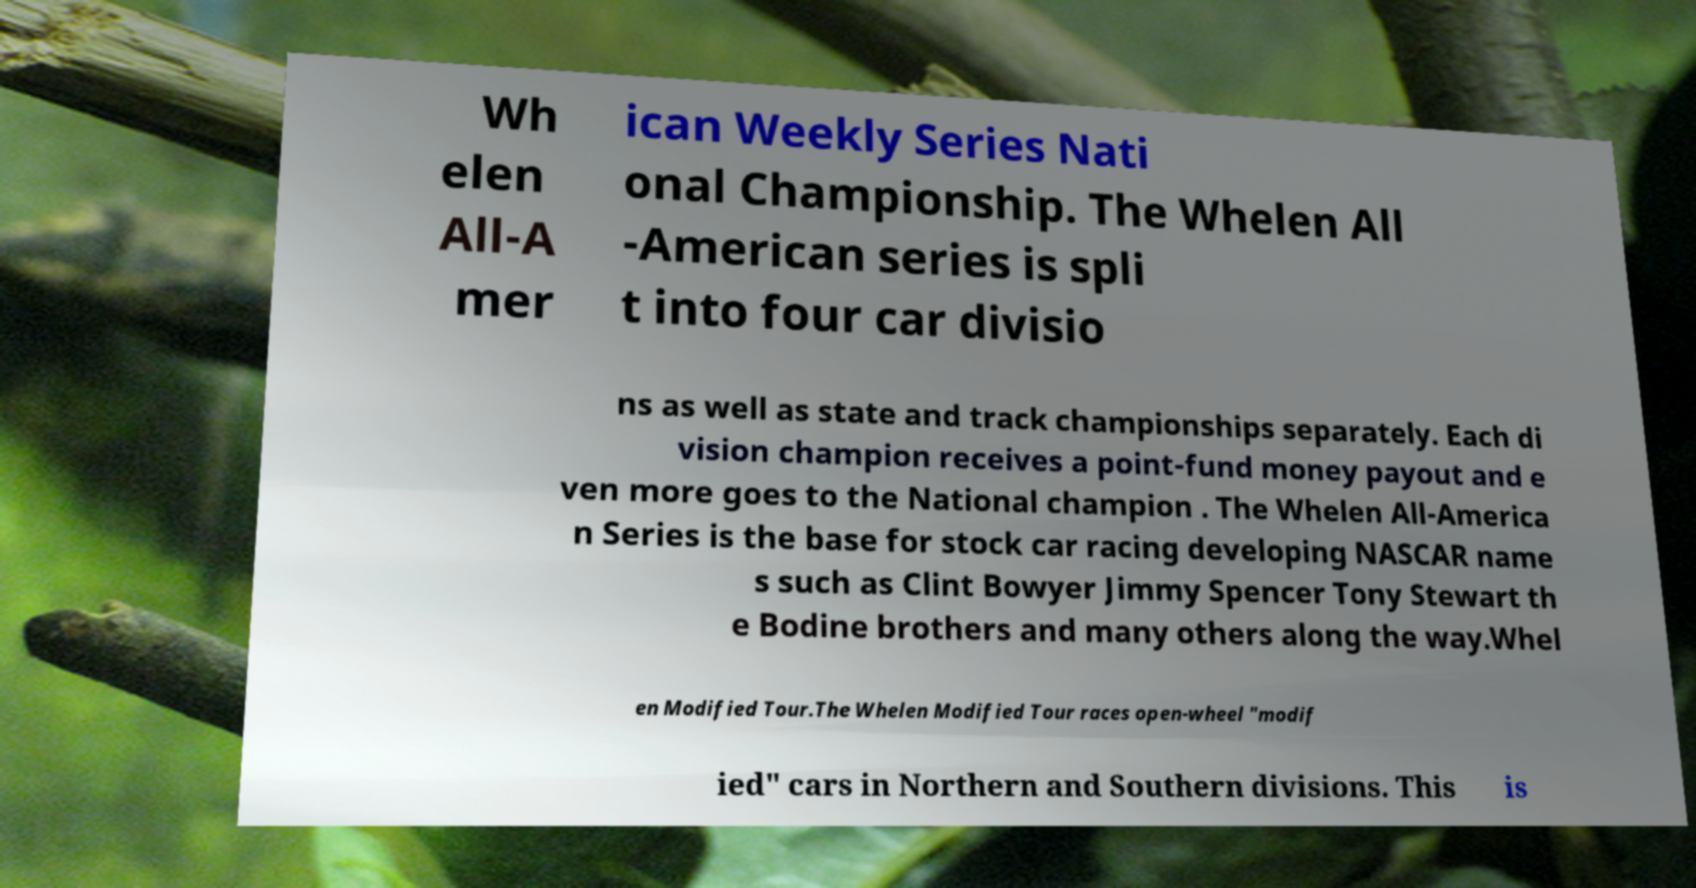Please read and relay the text visible in this image. What does it say? Wh elen All-A mer ican Weekly Series Nati onal Championship. The Whelen All -American series is spli t into four car divisio ns as well as state and track championships separately. Each di vision champion receives a point-fund money payout and e ven more goes to the National champion . The Whelen All-America n Series is the base for stock car racing developing NASCAR name s such as Clint Bowyer Jimmy Spencer Tony Stewart th e Bodine brothers and many others along the way.Whel en Modified Tour.The Whelen Modified Tour races open-wheel "modif ied" cars in Northern and Southern divisions. This is 